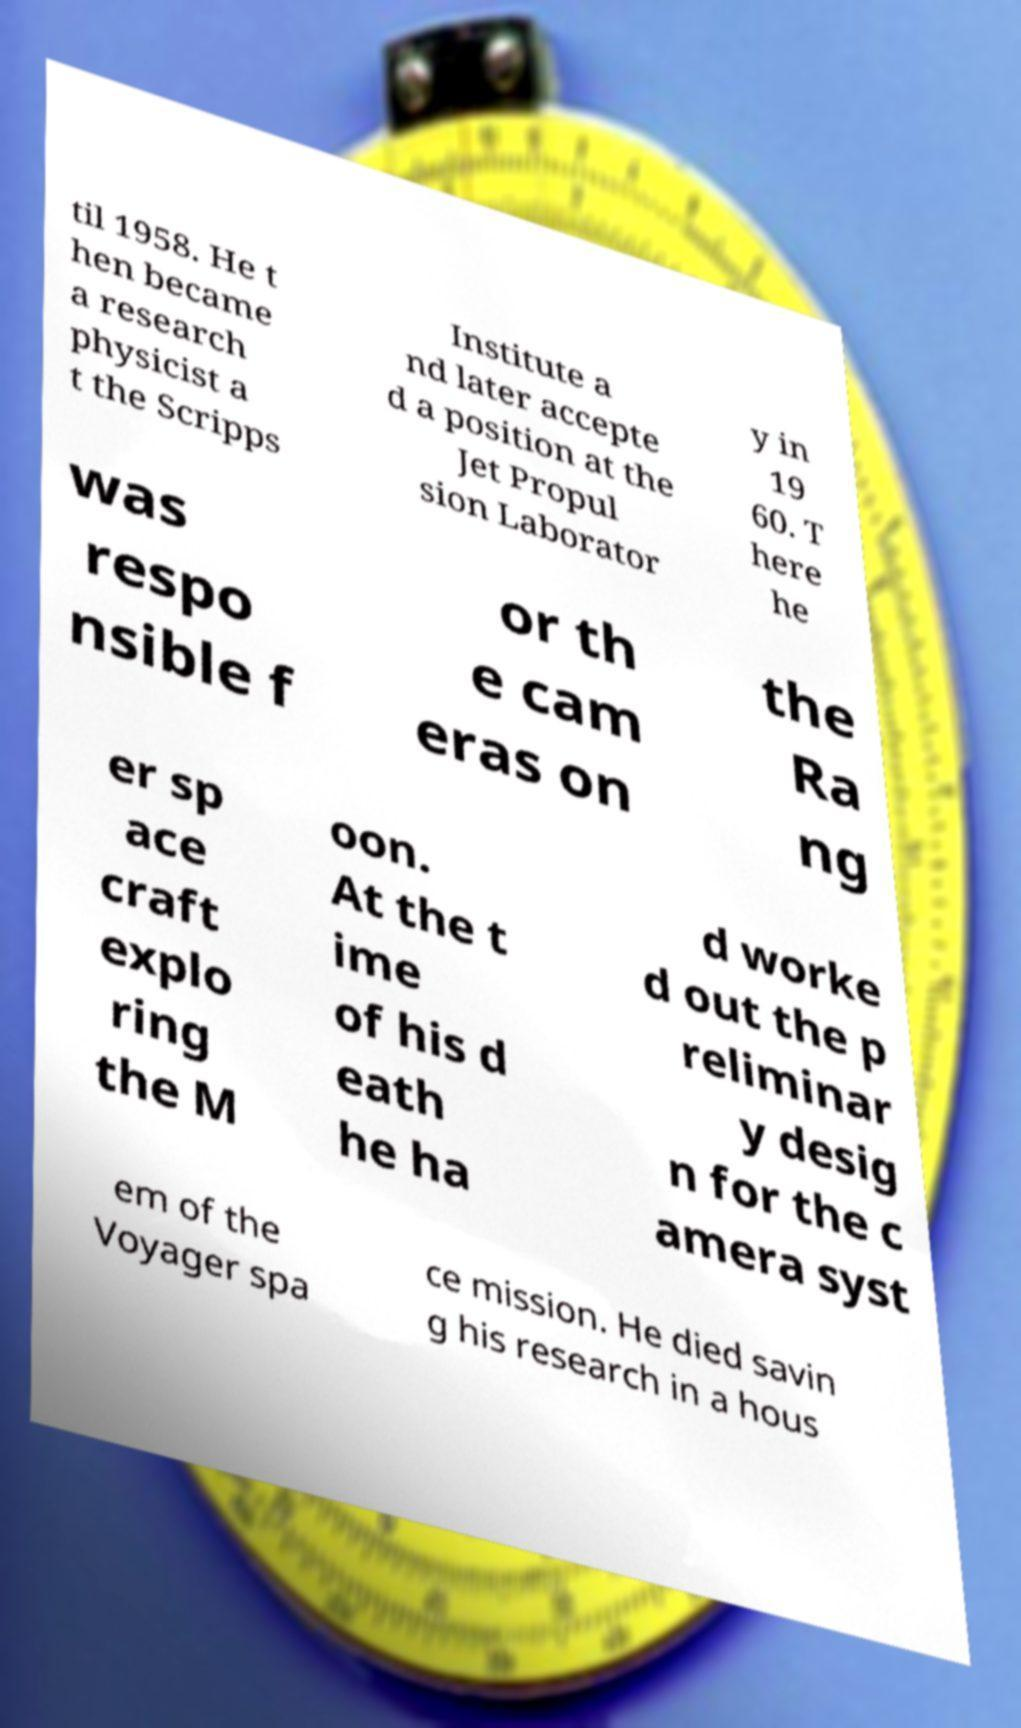For documentation purposes, I need the text within this image transcribed. Could you provide that? til 1958. He t hen became a research physicist a t the Scripps Institute a nd later accepte d a position at the Jet Propul sion Laborator y in 19 60. T here he was respo nsible f or th e cam eras on the Ra ng er sp ace craft explo ring the M oon. At the t ime of his d eath he ha d worke d out the p reliminar y desig n for the c amera syst em of the Voyager spa ce mission. He died savin g his research in a hous 